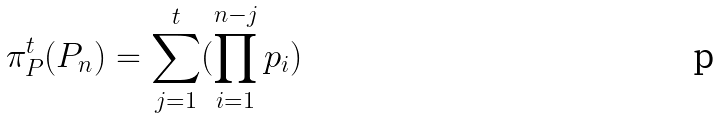<formula> <loc_0><loc_0><loc_500><loc_500>\pi _ { P } ^ { t } ( P _ { n } ) = \sum _ { j = 1 } ^ { t } ( \prod _ { i = 1 } ^ { n - j } p _ { i } )</formula> 